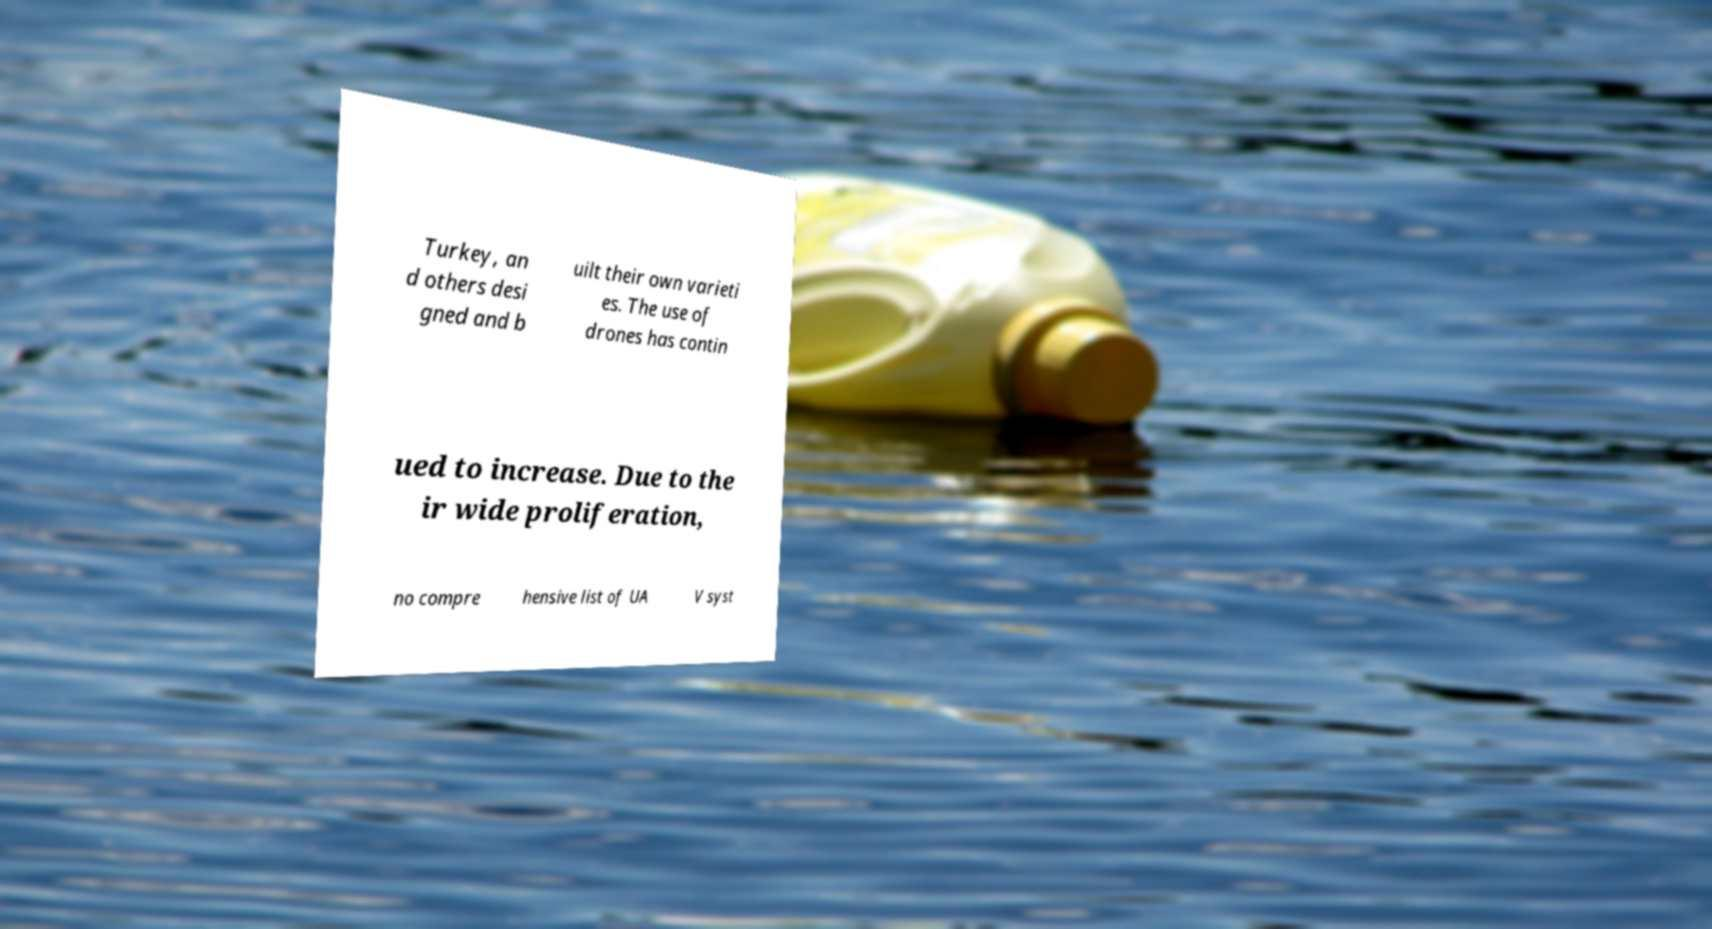I need the written content from this picture converted into text. Can you do that? Turkey, an d others desi gned and b uilt their own varieti es. The use of drones has contin ued to increase. Due to the ir wide proliferation, no compre hensive list of UA V syst 